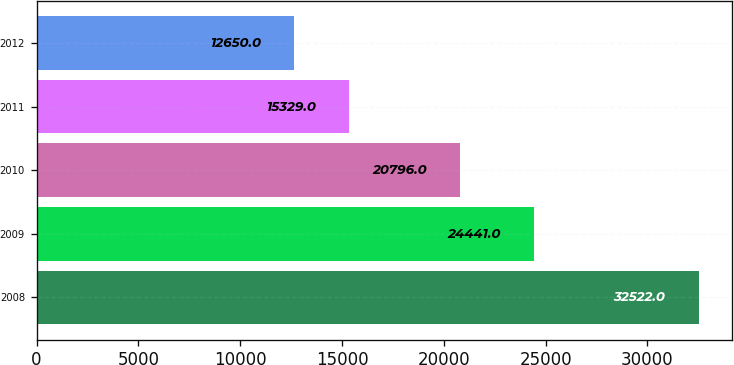Convert chart. <chart><loc_0><loc_0><loc_500><loc_500><bar_chart><fcel>2008<fcel>2009<fcel>2010<fcel>2011<fcel>2012<nl><fcel>32522<fcel>24441<fcel>20796<fcel>15329<fcel>12650<nl></chart> 